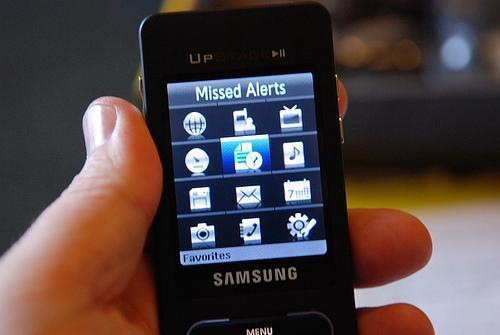How many phones are in the photo?
Give a very brief answer. 1. 